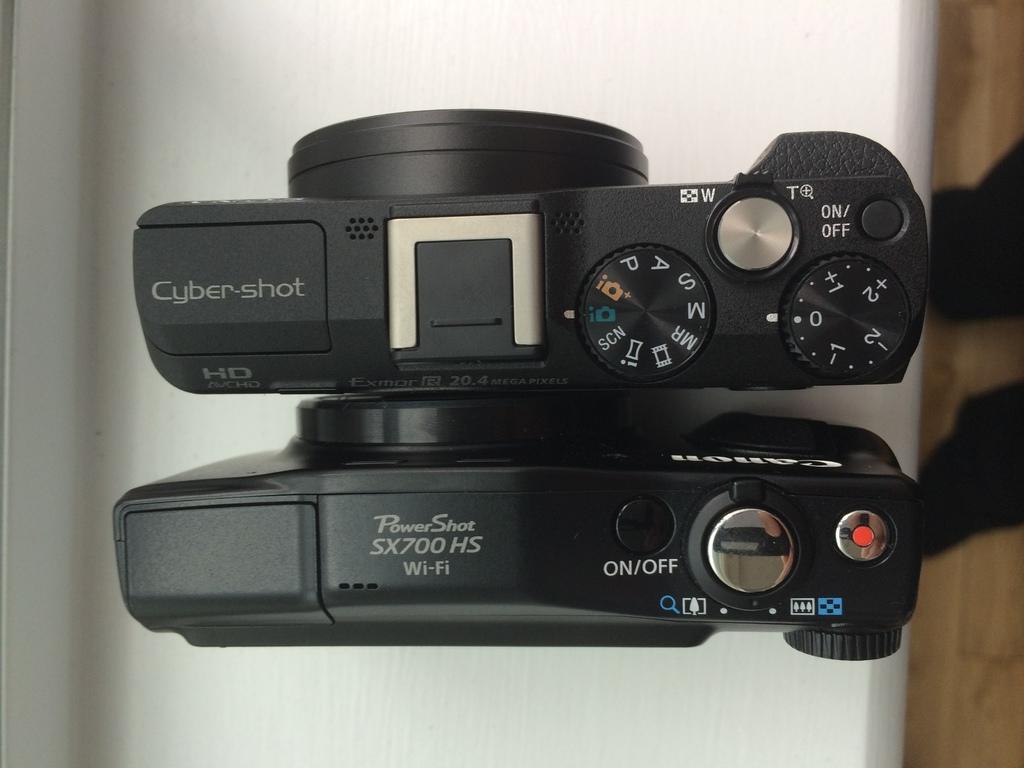What is the model number of the powershot?
Make the answer very short. Sx700 hs. 